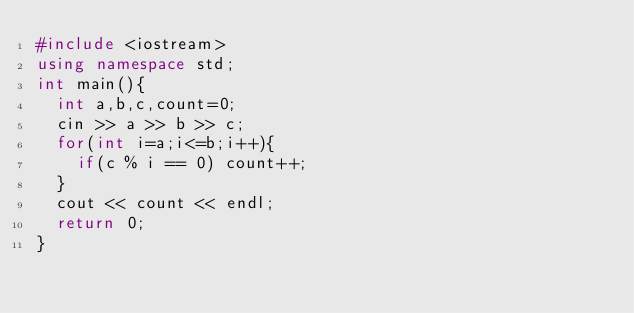<code> <loc_0><loc_0><loc_500><loc_500><_C++_>#include <iostream>
using namespace std;
int main(){
  int a,b,c,count=0;
  cin >> a >> b >> c;
  for(int i=a;i<=b;i++){
    if(c % i == 0) count++;
  }
  cout << count << endl;
  return 0;
}</code> 